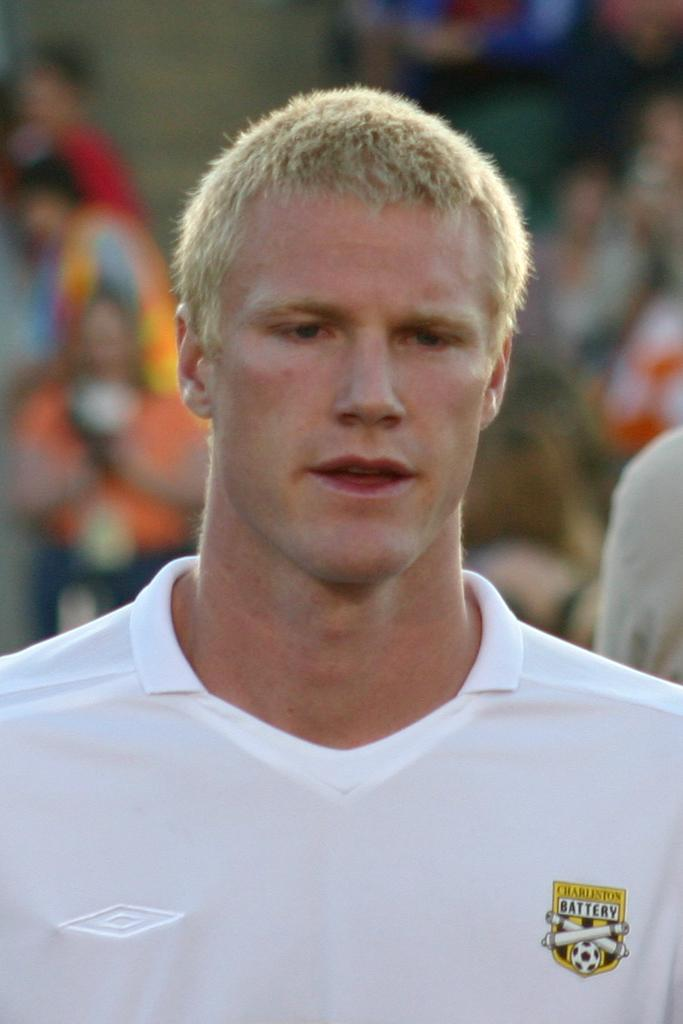<image>
Summarize the visual content of the image. the word battery is on the shirt of a person 